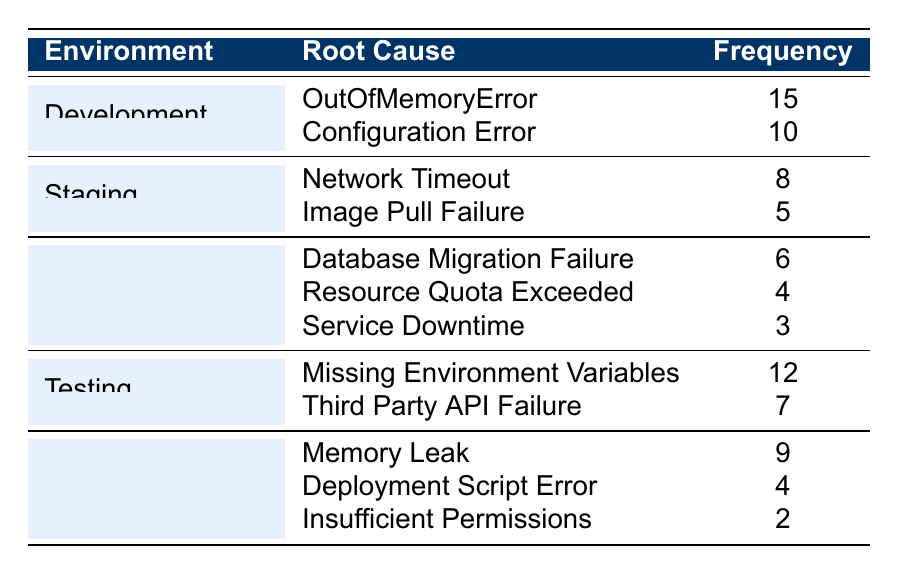What is the root cause of the highest frequency of deployment failures in the Development environment? The highest frequency of deployment failure in the Development environment is 15, which is caused by the OutOfMemoryError.
Answer: OutOfMemoryError How many times did deployment failures occur in the Staging environment? In the Staging environment, the frequency of deployment failures is the sum of Network Timeout (8) and Image Pull Failure (5), which equals 13.
Answer: 13 Is there a deployment failure related to 'Insufficient Permissions' in the Production environment? Since ‘Insufficient Permissions’ is listed only under Quality Assurance, it indicates that there are no deployment failures for this root cause in the Production environment.
Answer: No Which environment has the second highest deployment failure frequency? The Testing environment has a total frequency of 19, second only to Development which has 25. This can be calculated based on the frequency of Missing Environment Variables (12) and Third Party API Failure (7).
Answer: Testing What is the total frequency of deployment failures across all environments? To find the total frequency of deployment failures, sum the values for all root causes: 15 + 10 + 8 + 5 + 6 + 4 + 3 + 12 + 7 + 9 + 4 + 2 = 81.
Answer: 81 Which root cause has the lowest frequency overall, and in which environment does it occur? The root cause with the lowest frequency is 'Insufficient Permissions' occurring in the Quality Assurance environment with a frequency of 2.
Answer: Insufficient Permissions, Quality Assurance What is the average frequency of deployment failures in the Production environment? The Production environment has three root causes with frequencies of 6, 4, and 3. The average is calculated as (6 + 4 + 3) / 3 = 4.33.
Answer: 4.33 How many total unique root causes are listed in the Quality Assurance environment? In the Quality Assurance environment, there are three unique root causes: Memory Leak, Deployment Script Error, and Insufficient Permissions.
Answer: 3 Which environment has more deployment failures, Development or Testing? The Development environment has a total of 25 (15 + 10) deployment failures, while the Testing environment has 19 (12 + 7). Therefore, Development has more failures.
Answer: Development Are there fewer deployment failures in the Production environment compared to the Staging environment? Summing the frequencies reveals Production has 13 (6 + 4 + 3) failures while Staging has 13 (8 + 5), indicating they are equal.
Answer: No 